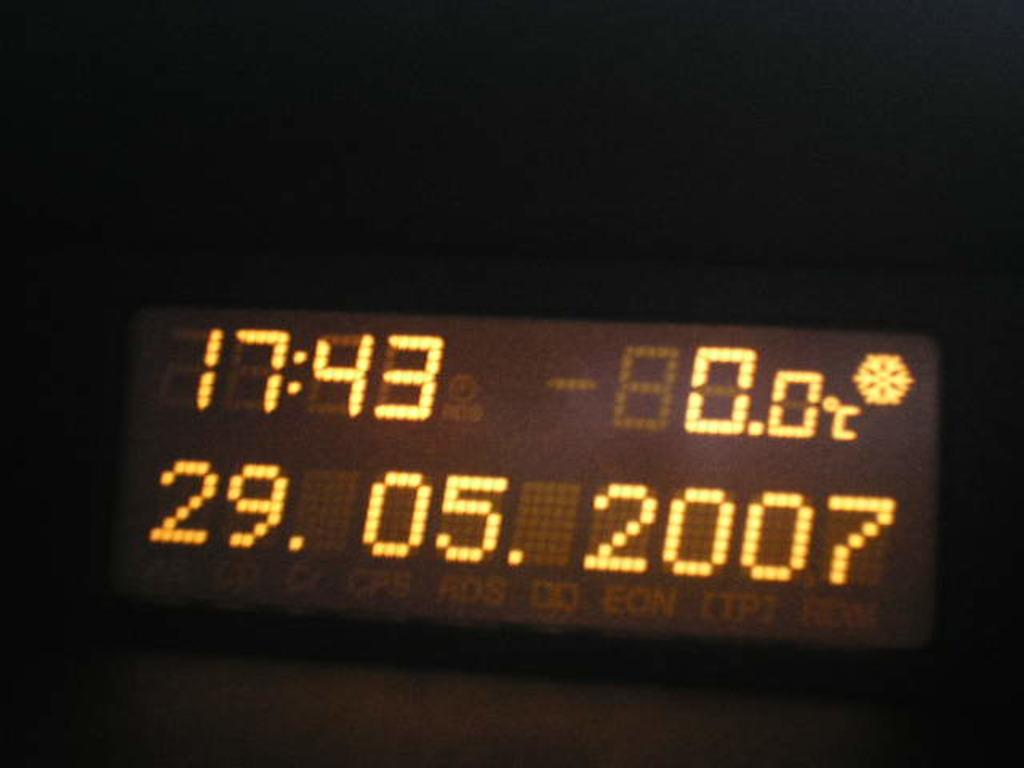<image>
Share a concise interpretation of the image provided. A display with the time at 17:43 on May 29th 2007 